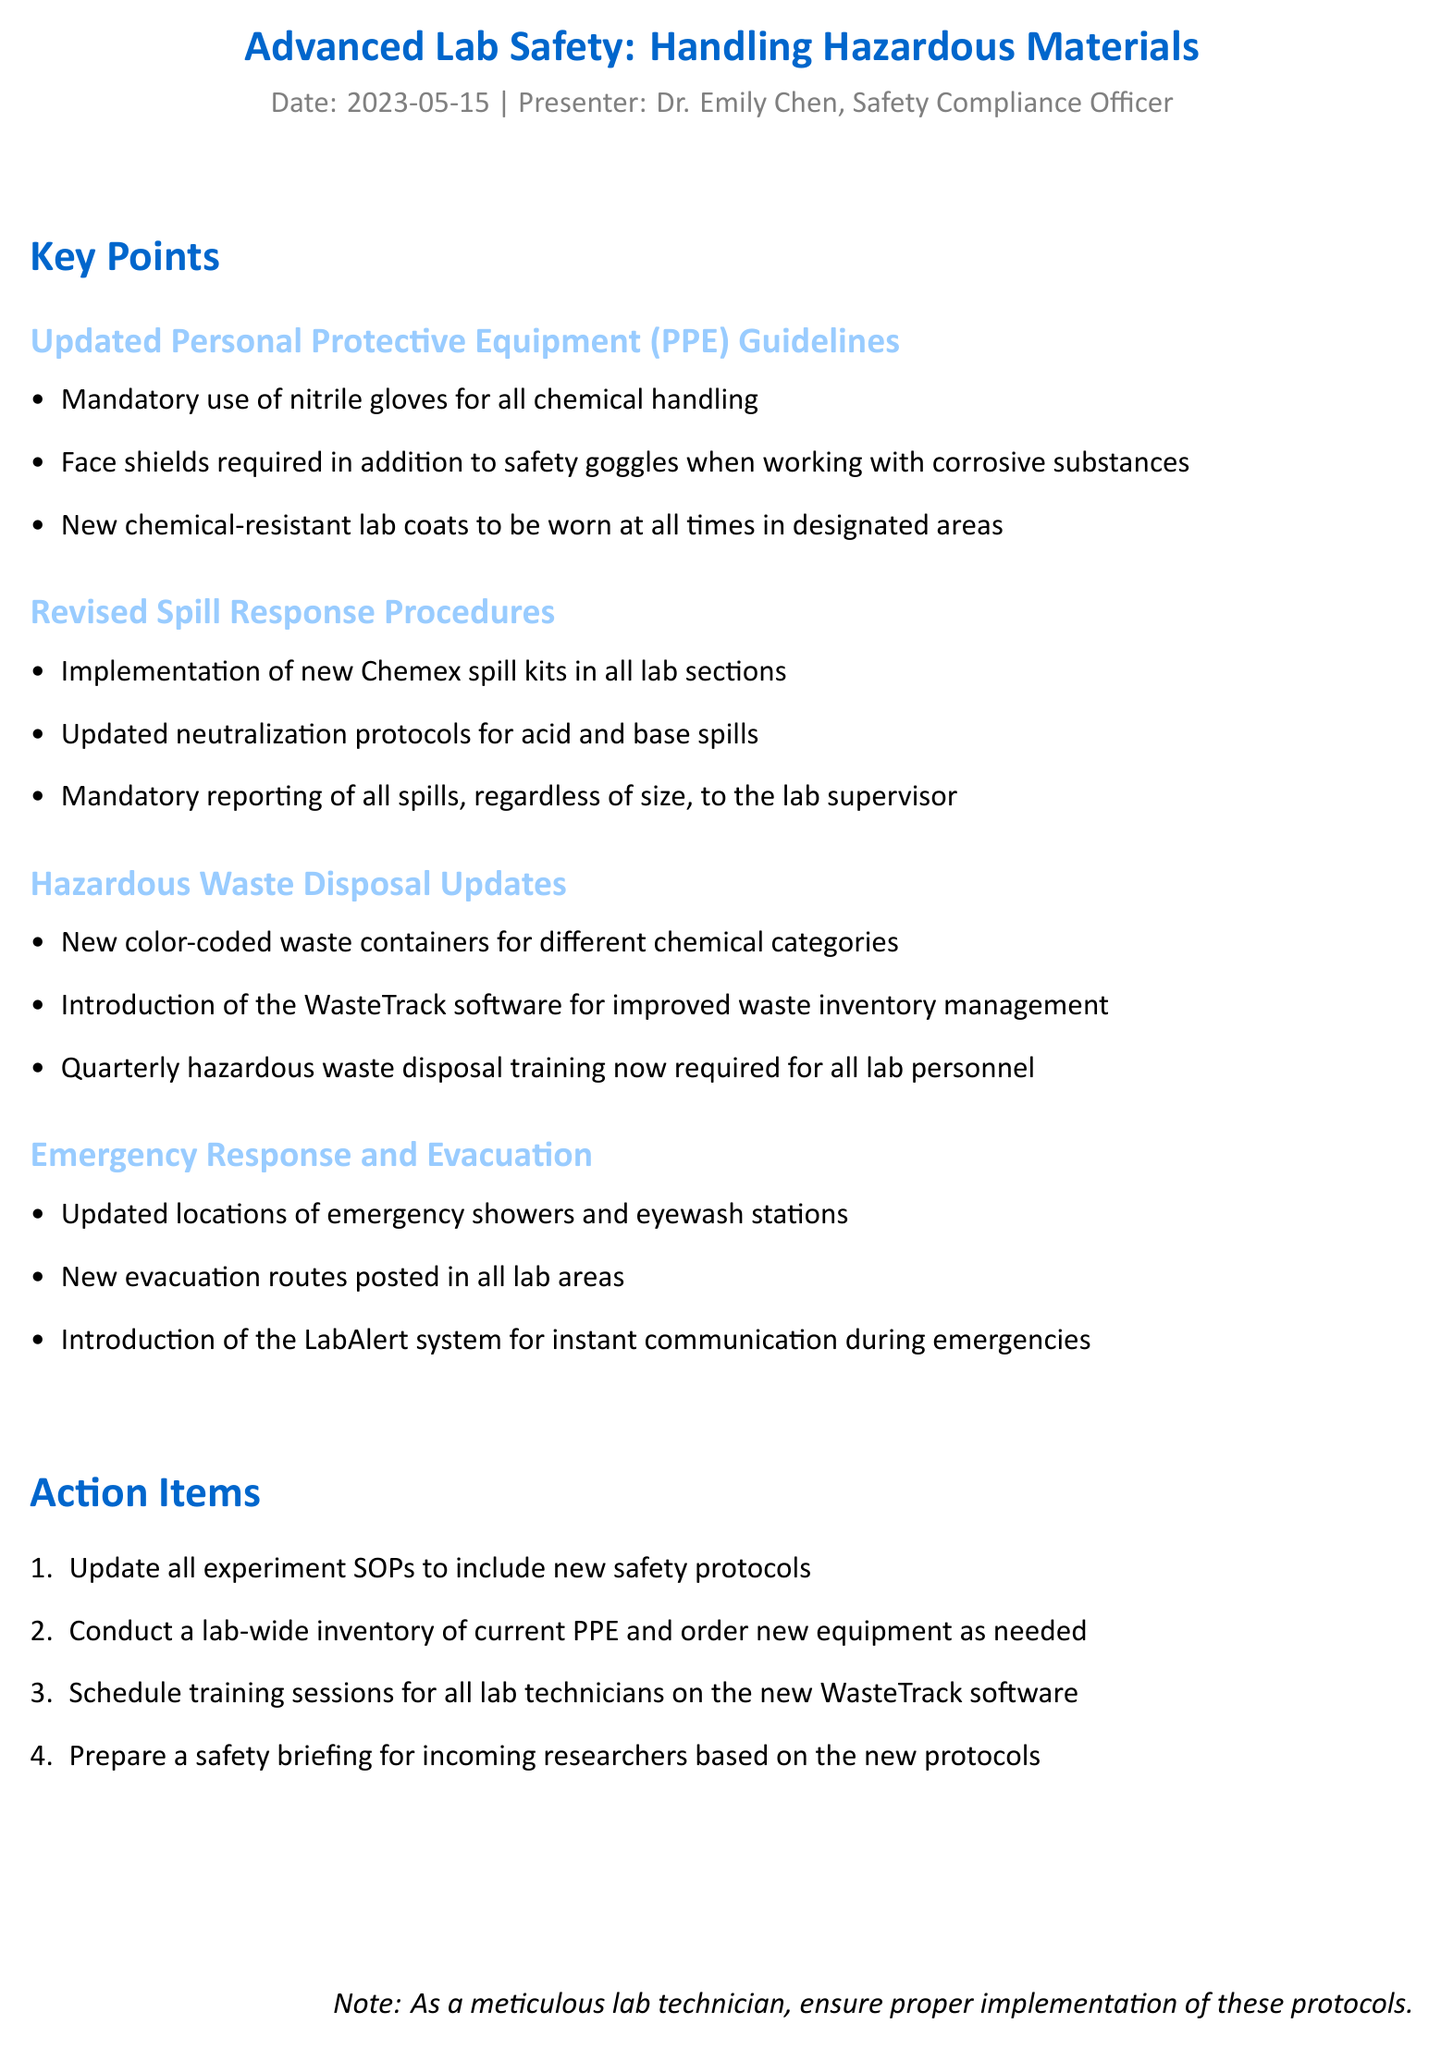What is the title of the seminar? The title of the seminar is mentioned at the beginning of the document.
Answer: Advanced Lab Safety: Handling Hazardous Materials Who presented the seminar? The document states the name of the presenter in the seminar details section.
Answer: Dr. Emily Chen What date was the seminar held? The date of the seminar is specified in the seminar details.
Answer: 2023-05-15 What is mandatory for chemical handling? The updated PPE guidelines specify the required equipment for chemical handling.
Answer: Nitrile gloves What should be worn in addition to safety goggles when working with corrosive substances? The guidelines clearly indicate additional protective equipment required for corrosive materials.
Answer: Face shields How many action items are listed in the document? The action items section details specific tasks, which can be counted.
Answer: Four What new system is introduced for waste inventory management? The hazardous waste disposal updates discuss a new system introduced for managing waste.
Answer: WasteTrack When is the quarterly hazardous waste disposal training required? The document mentions a specific timeframe for training frequency in the hazardous waste disposal updates.
Answer: Quarterly What must be reported to the lab supervisor? The spill response procedures detail what events must be reported.
Answer: All spills 